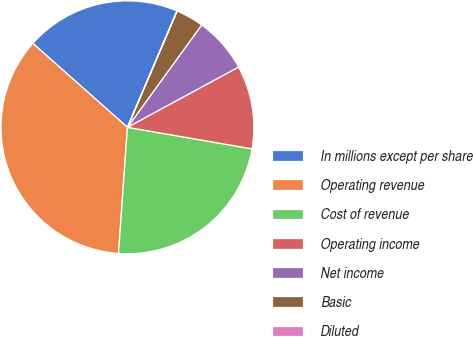Convert chart to OTSL. <chart><loc_0><loc_0><loc_500><loc_500><pie_chart><fcel>In millions except per share<fcel>Operating revenue<fcel>Cost of revenue<fcel>Operating income<fcel>Net income<fcel>Basic<fcel>Diluted<nl><fcel>19.86%<fcel>35.43%<fcel>23.4%<fcel>10.64%<fcel>7.1%<fcel>3.56%<fcel>0.02%<nl></chart> 